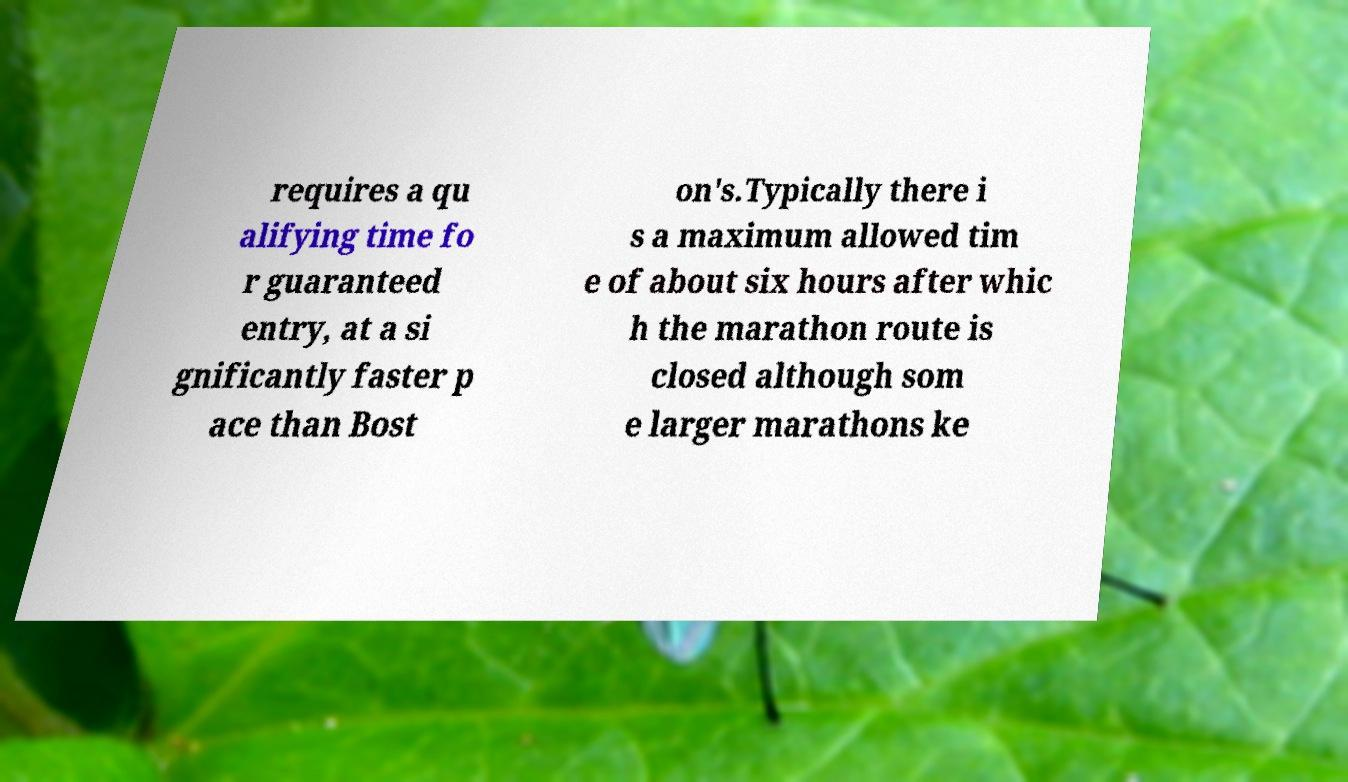Please identify and transcribe the text found in this image. requires a qu alifying time fo r guaranteed entry, at a si gnificantly faster p ace than Bost on's.Typically there i s a maximum allowed tim e of about six hours after whic h the marathon route is closed although som e larger marathons ke 